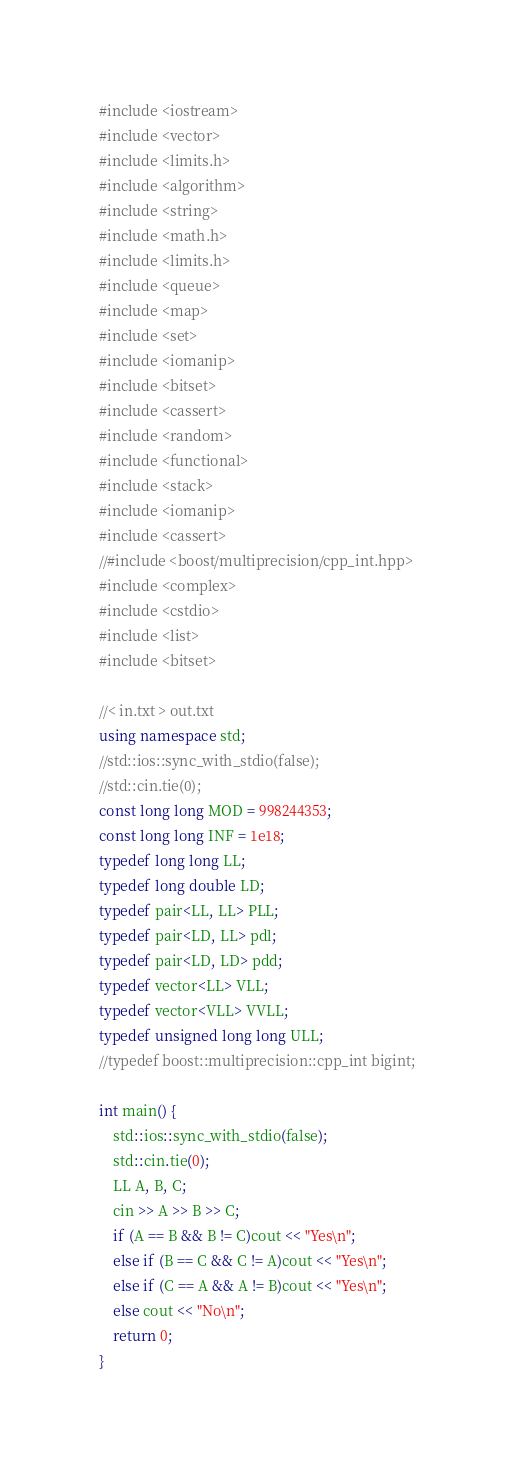<code> <loc_0><loc_0><loc_500><loc_500><_C++_>#include <iostream>
#include <vector>
#include <limits.h>
#include <algorithm>
#include <string>
#include <math.h>
#include <limits.h>
#include <queue>
#include <map>
#include <set>
#include <iomanip>
#include <bitset>
#include <cassert>
#include <random>
#include <functional>
#include <stack>
#include <iomanip>
#include <cassert>
//#include <boost/multiprecision/cpp_int.hpp>
#include <complex>
#include <cstdio>
#include <list>
#include <bitset>

//< in.txt > out.txt
using namespace std;
//std::ios::sync_with_stdio(false);
//std::cin.tie(0);
const long long MOD = 998244353;
const long long INF = 1e18;
typedef long long LL;
typedef long double LD;
typedef pair<LL, LL> PLL;
typedef pair<LD, LL> pdl;
typedef pair<LD, LD> pdd;
typedef vector<LL> VLL;
typedef vector<VLL> VVLL;
typedef unsigned long long ULL;
//typedef boost::multiprecision::cpp_int bigint;

int main() {
	std::ios::sync_with_stdio(false);
	std::cin.tie(0);
	LL A, B, C;
	cin >> A >> B >> C;
	if (A == B && B != C)cout << "Yes\n";
	else if (B == C && C != A)cout << "Yes\n";
	else if (C == A && A != B)cout << "Yes\n";
	else cout << "No\n";
	return 0;
}
</code> 